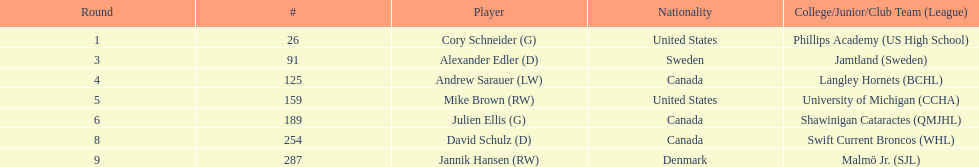What is the name of the last player on this chart? Jannik Hansen (RW). 